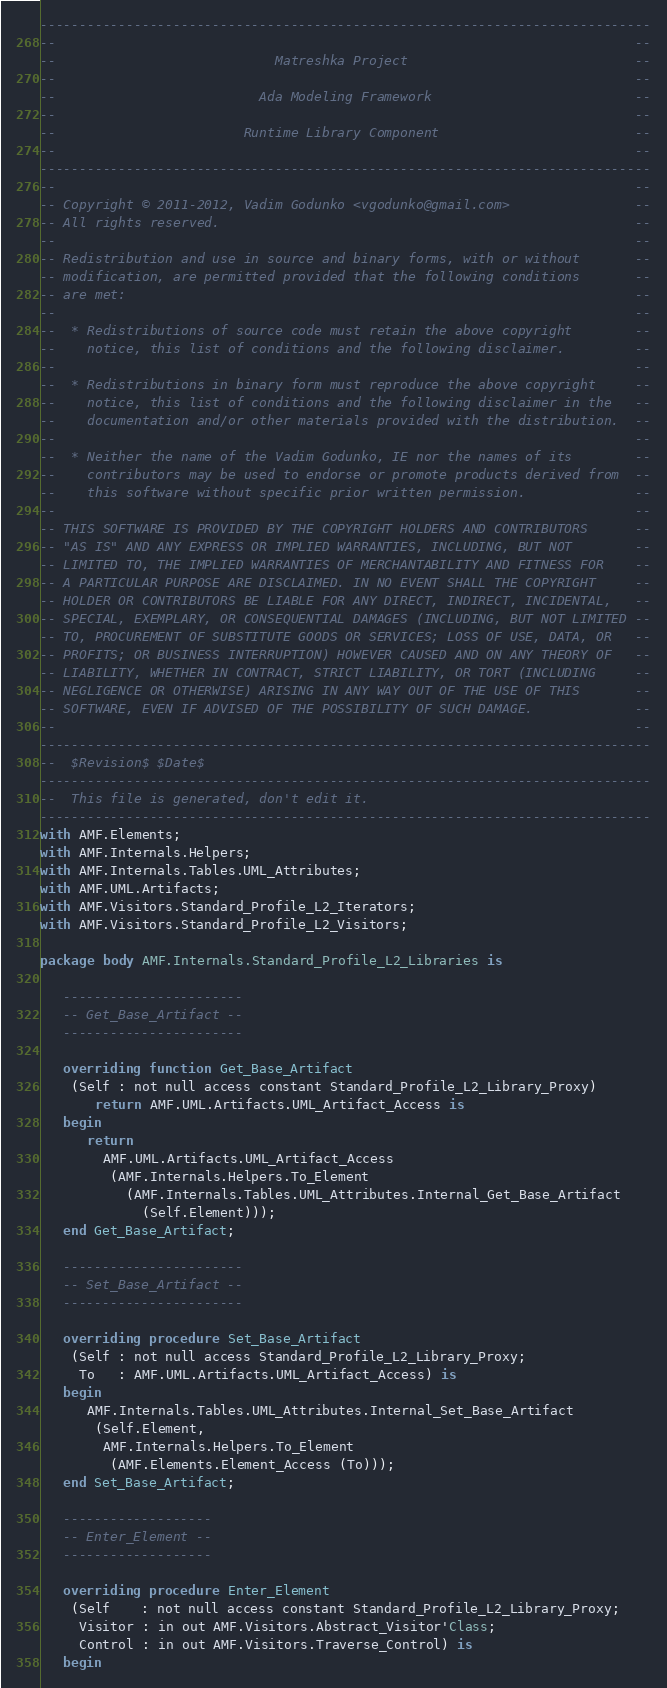Convert code to text. <code><loc_0><loc_0><loc_500><loc_500><_Ada_>------------------------------------------------------------------------------
--                                                                          --
--                            Matreshka Project                             --
--                                                                          --
--                          Ada Modeling Framework                          --
--                                                                          --
--                        Runtime Library Component                         --
--                                                                          --
------------------------------------------------------------------------------
--                                                                          --
-- Copyright © 2011-2012, Vadim Godunko <vgodunko@gmail.com>                --
-- All rights reserved.                                                     --
--                                                                          --
-- Redistribution and use in source and binary forms, with or without       --
-- modification, are permitted provided that the following conditions       --
-- are met:                                                                 --
--                                                                          --
--  * Redistributions of source code must retain the above copyright        --
--    notice, this list of conditions and the following disclaimer.         --
--                                                                          --
--  * Redistributions in binary form must reproduce the above copyright     --
--    notice, this list of conditions and the following disclaimer in the   --
--    documentation and/or other materials provided with the distribution.  --
--                                                                          --
--  * Neither the name of the Vadim Godunko, IE nor the names of its        --
--    contributors may be used to endorse or promote products derived from  --
--    this software without specific prior written permission.              --
--                                                                          --
-- THIS SOFTWARE IS PROVIDED BY THE COPYRIGHT HOLDERS AND CONTRIBUTORS      --
-- "AS IS" AND ANY EXPRESS OR IMPLIED WARRANTIES, INCLUDING, BUT NOT        --
-- LIMITED TO, THE IMPLIED WARRANTIES OF MERCHANTABILITY AND FITNESS FOR    --
-- A PARTICULAR PURPOSE ARE DISCLAIMED. IN NO EVENT SHALL THE COPYRIGHT     --
-- HOLDER OR CONTRIBUTORS BE LIABLE FOR ANY DIRECT, INDIRECT, INCIDENTAL,   --
-- SPECIAL, EXEMPLARY, OR CONSEQUENTIAL DAMAGES (INCLUDING, BUT NOT LIMITED --
-- TO, PROCUREMENT OF SUBSTITUTE GOODS OR SERVICES; LOSS OF USE, DATA, OR   --
-- PROFITS; OR BUSINESS INTERRUPTION) HOWEVER CAUSED AND ON ANY THEORY OF   --
-- LIABILITY, WHETHER IN CONTRACT, STRICT LIABILITY, OR TORT (INCLUDING     --
-- NEGLIGENCE OR OTHERWISE) ARISING IN ANY WAY OUT OF THE USE OF THIS       --
-- SOFTWARE, EVEN IF ADVISED OF THE POSSIBILITY OF SUCH DAMAGE.             --
--                                                                          --
------------------------------------------------------------------------------
--  $Revision$ $Date$
------------------------------------------------------------------------------
--  This file is generated, don't edit it.
------------------------------------------------------------------------------
with AMF.Elements;
with AMF.Internals.Helpers;
with AMF.Internals.Tables.UML_Attributes;
with AMF.UML.Artifacts;
with AMF.Visitors.Standard_Profile_L2_Iterators;
with AMF.Visitors.Standard_Profile_L2_Visitors;

package body AMF.Internals.Standard_Profile_L2_Libraries is

   -----------------------
   -- Get_Base_Artifact --
   -----------------------

   overriding function Get_Base_Artifact
    (Self : not null access constant Standard_Profile_L2_Library_Proxy)
       return AMF.UML.Artifacts.UML_Artifact_Access is
   begin
      return
        AMF.UML.Artifacts.UML_Artifact_Access
         (AMF.Internals.Helpers.To_Element
           (AMF.Internals.Tables.UML_Attributes.Internal_Get_Base_Artifact
             (Self.Element)));
   end Get_Base_Artifact;

   -----------------------
   -- Set_Base_Artifact --
   -----------------------

   overriding procedure Set_Base_Artifact
    (Self : not null access Standard_Profile_L2_Library_Proxy;
     To   : AMF.UML.Artifacts.UML_Artifact_Access) is
   begin
      AMF.Internals.Tables.UML_Attributes.Internal_Set_Base_Artifact
       (Self.Element,
        AMF.Internals.Helpers.To_Element
         (AMF.Elements.Element_Access (To)));
   end Set_Base_Artifact;

   -------------------
   -- Enter_Element --
   -------------------

   overriding procedure Enter_Element
    (Self    : not null access constant Standard_Profile_L2_Library_Proxy;
     Visitor : in out AMF.Visitors.Abstract_Visitor'Class;
     Control : in out AMF.Visitors.Traverse_Control) is
   begin</code> 